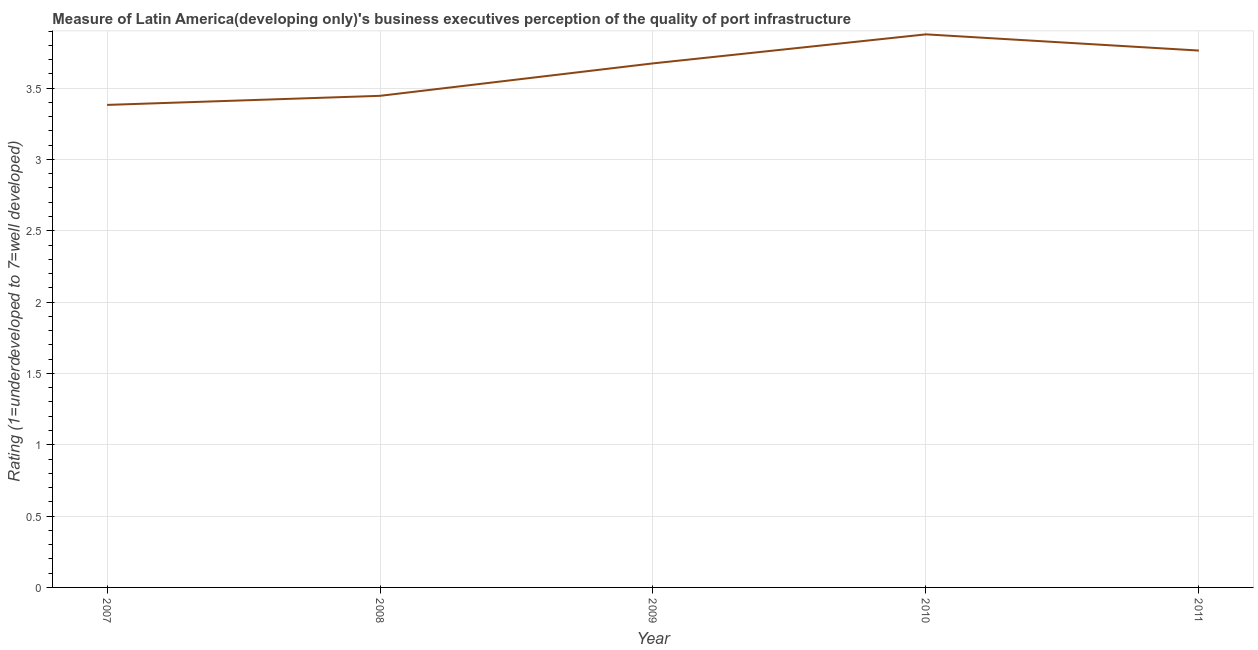What is the rating measuring quality of port infrastructure in 2011?
Your response must be concise. 3.76. Across all years, what is the maximum rating measuring quality of port infrastructure?
Keep it short and to the point. 3.88. Across all years, what is the minimum rating measuring quality of port infrastructure?
Provide a short and direct response. 3.38. In which year was the rating measuring quality of port infrastructure maximum?
Ensure brevity in your answer.  2010. What is the sum of the rating measuring quality of port infrastructure?
Offer a very short reply. 18.14. What is the difference between the rating measuring quality of port infrastructure in 2009 and 2011?
Give a very brief answer. -0.09. What is the average rating measuring quality of port infrastructure per year?
Make the answer very short. 3.63. What is the median rating measuring quality of port infrastructure?
Your response must be concise. 3.67. In how many years, is the rating measuring quality of port infrastructure greater than 2 ?
Make the answer very short. 5. What is the ratio of the rating measuring quality of port infrastructure in 2009 to that in 2010?
Keep it short and to the point. 0.95. Is the difference between the rating measuring quality of port infrastructure in 2008 and 2009 greater than the difference between any two years?
Your response must be concise. No. What is the difference between the highest and the second highest rating measuring quality of port infrastructure?
Ensure brevity in your answer.  0.11. Is the sum of the rating measuring quality of port infrastructure in 2010 and 2011 greater than the maximum rating measuring quality of port infrastructure across all years?
Ensure brevity in your answer.  Yes. What is the difference between the highest and the lowest rating measuring quality of port infrastructure?
Your answer should be very brief. 0.49. In how many years, is the rating measuring quality of port infrastructure greater than the average rating measuring quality of port infrastructure taken over all years?
Give a very brief answer. 3. How many lines are there?
Your response must be concise. 1. What is the title of the graph?
Ensure brevity in your answer.  Measure of Latin America(developing only)'s business executives perception of the quality of port infrastructure. What is the label or title of the X-axis?
Offer a terse response. Year. What is the label or title of the Y-axis?
Provide a short and direct response. Rating (1=underdeveloped to 7=well developed) . What is the Rating (1=underdeveloped to 7=well developed)  in 2007?
Give a very brief answer. 3.38. What is the Rating (1=underdeveloped to 7=well developed)  in 2008?
Your answer should be very brief. 3.45. What is the Rating (1=underdeveloped to 7=well developed)  in 2009?
Your answer should be compact. 3.67. What is the Rating (1=underdeveloped to 7=well developed)  in 2010?
Your answer should be very brief. 3.88. What is the Rating (1=underdeveloped to 7=well developed)  in 2011?
Your answer should be very brief. 3.76. What is the difference between the Rating (1=underdeveloped to 7=well developed)  in 2007 and 2008?
Keep it short and to the point. -0.06. What is the difference between the Rating (1=underdeveloped to 7=well developed)  in 2007 and 2009?
Ensure brevity in your answer.  -0.29. What is the difference between the Rating (1=underdeveloped to 7=well developed)  in 2007 and 2010?
Keep it short and to the point. -0.49. What is the difference between the Rating (1=underdeveloped to 7=well developed)  in 2007 and 2011?
Offer a terse response. -0.38. What is the difference between the Rating (1=underdeveloped to 7=well developed)  in 2008 and 2009?
Your answer should be compact. -0.23. What is the difference between the Rating (1=underdeveloped to 7=well developed)  in 2008 and 2010?
Give a very brief answer. -0.43. What is the difference between the Rating (1=underdeveloped to 7=well developed)  in 2008 and 2011?
Your response must be concise. -0.32. What is the difference between the Rating (1=underdeveloped to 7=well developed)  in 2009 and 2010?
Provide a short and direct response. -0.2. What is the difference between the Rating (1=underdeveloped to 7=well developed)  in 2009 and 2011?
Your answer should be very brief. -0.09. What is the difference between the Rating (1=underdeveloped to 7=well developed)  in 2010 and 2011?
Offer a very short reply. 0.11. What is the ratio of the Rating (1=underdeveloped to 7=well developed)  in 2007 to that in 2008?
Provide a succinct answer. 0.98. What is the ratio of the Rating (1=underdeveloped to 7=well developed)  in 2007 to that in 2009?
Offer a terse response. 0.92. What is the ratio of the Rating (1=underdeveloped to 7=well developed)  in 2007 to that in 2010?
Your answer should be compact. 0.87. What is the ratio of the Rating (1=underdeveloped to 7=well developed)  in 2007 to that in 2011?
Give a very brief answer. 0.9. What is the ratio of the Rating (1=underdeveloped to 7=well developed)  in 2008 to that in 2009?
Your answer should be very brief. 0.94. What is the ratio of the Rating (1=underdeveloped to 7=well developed)  in 2008 to that in 2010?
Make the answer very short. 0.89. What is the ratio of the Rating (1=underdeveloped to 7=well developed)  in 2008 to that in 2011?
Your answer should be very brief. 0.92. What is the ratio of the Rating (1=underdeveloped to 7=well developed)  in 2009 to that in 2010?
Provide a succinct answer. 0.95. What is the ratio of the Rating (1=underdeveloped to 7=well developed)  in 2010 to that in 2011?
Your answer should be compact. 1.03. 